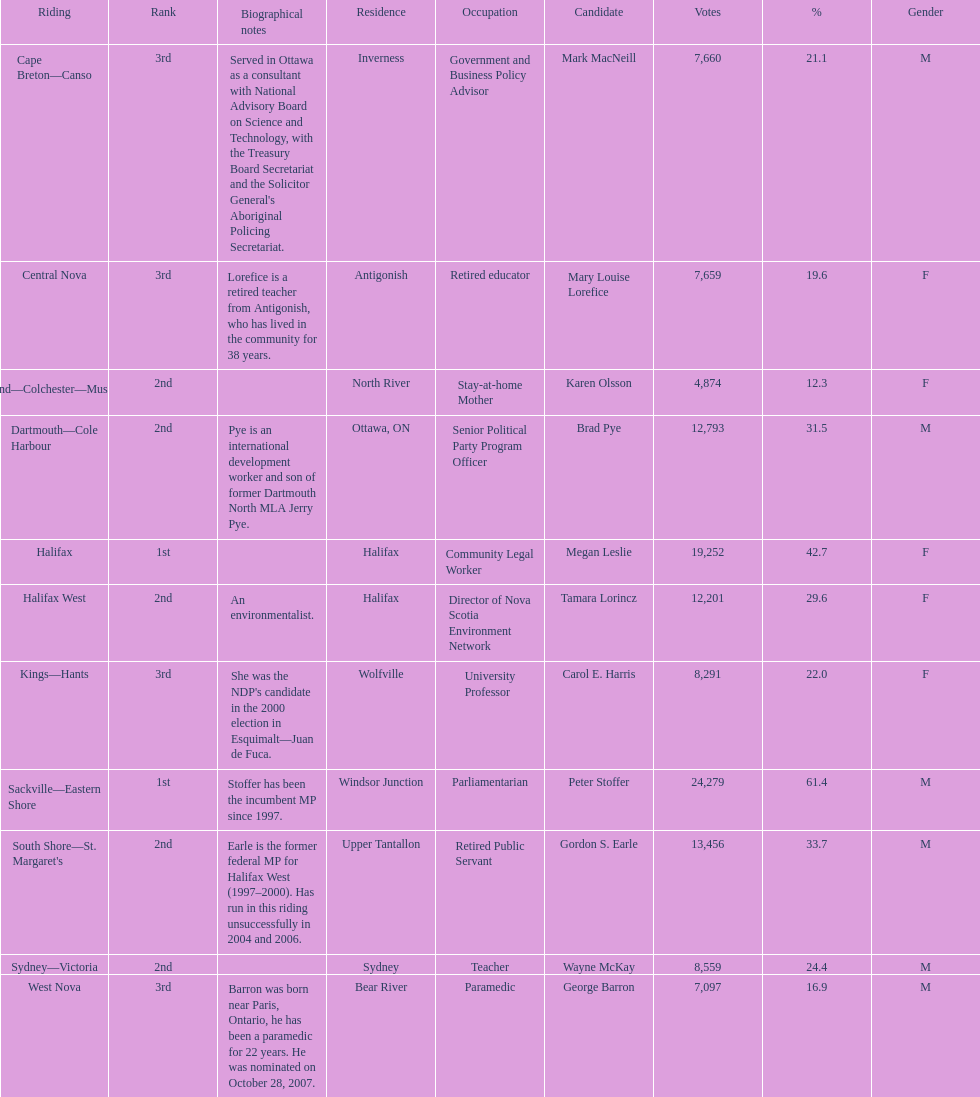How many candidates were from halifax? 2. 